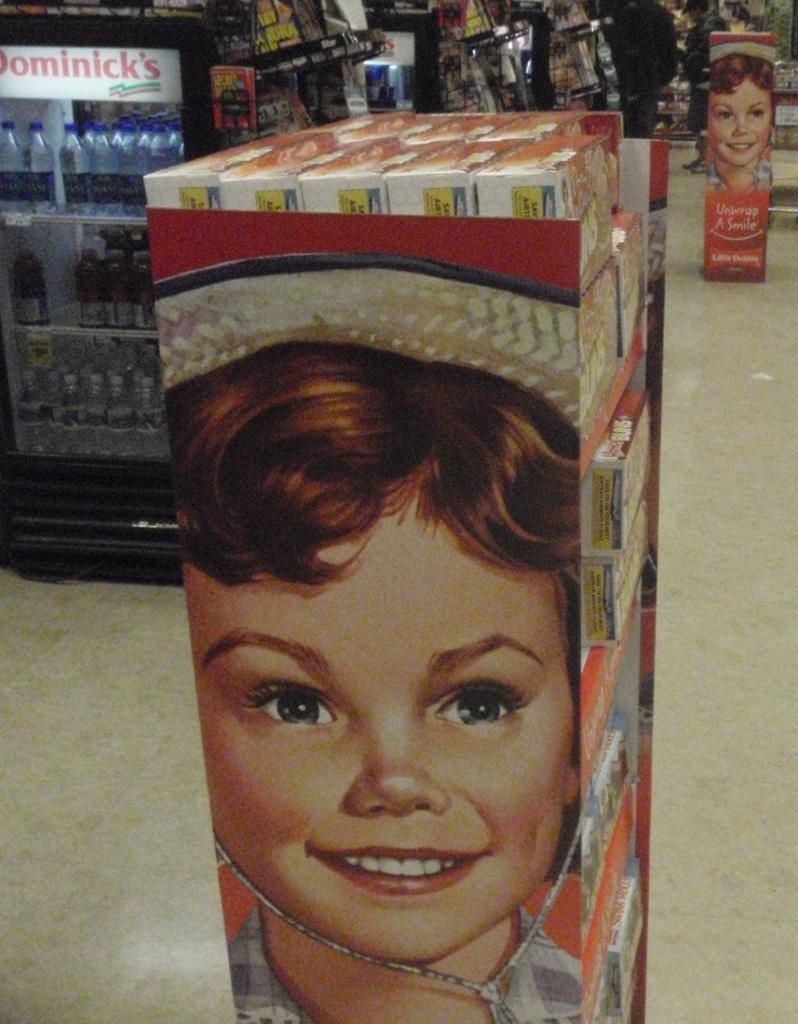What type of establishment is depicted in the image? The image appears to depict a store. What is one specific item visible in the store? There is a small refrigerator in the image. What can be seen on the shelves in the store? There are items on shelves in the image. How does the store fold its customers in the image? The store does not fold its customers in the image; it is a physical establishment where people can shop for items. 